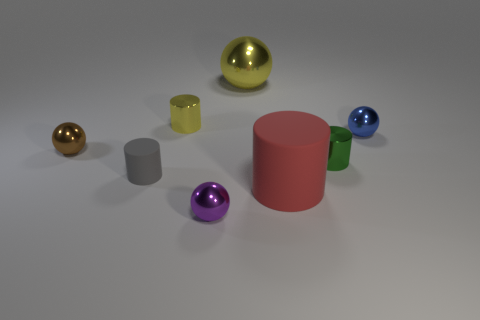Do the tiny brown object and the yellow thing that is on the left side of the tiny purple sphere have the same shape?
Ensure brevity in your answer.  No. Does the large thing that is behind the small green object have the same shape as the gray object?
Your response must be concise. No. How many gray things are either small metallic objects or small cylinders?
Provide a succinct answer. 1. Is the number of tiny things that are on the right side of the green thing the same as the number of small green cylinders?
Provide a succinct answer. Yes. What is the color of the big thing that is the same shape as the tiny purple thing?
Give a very brief answer. Yellow. What number of brown shiny objects have the same shape as the purple metal thing?
Make the answer very short. 1. What material is the tiny cylinder that is the same color as the large ball?
Ensure brevity in your answer.  Metal. What number of big objects are there?
Your response must be concise. 2. Is there a tiny blue sphere made of the same material as the green cylinder?
Offer a very short reply. Yes. There is a metal cylinder that is the same color as the big shiny thing; what size is it?
Offer a terse response. Small. 